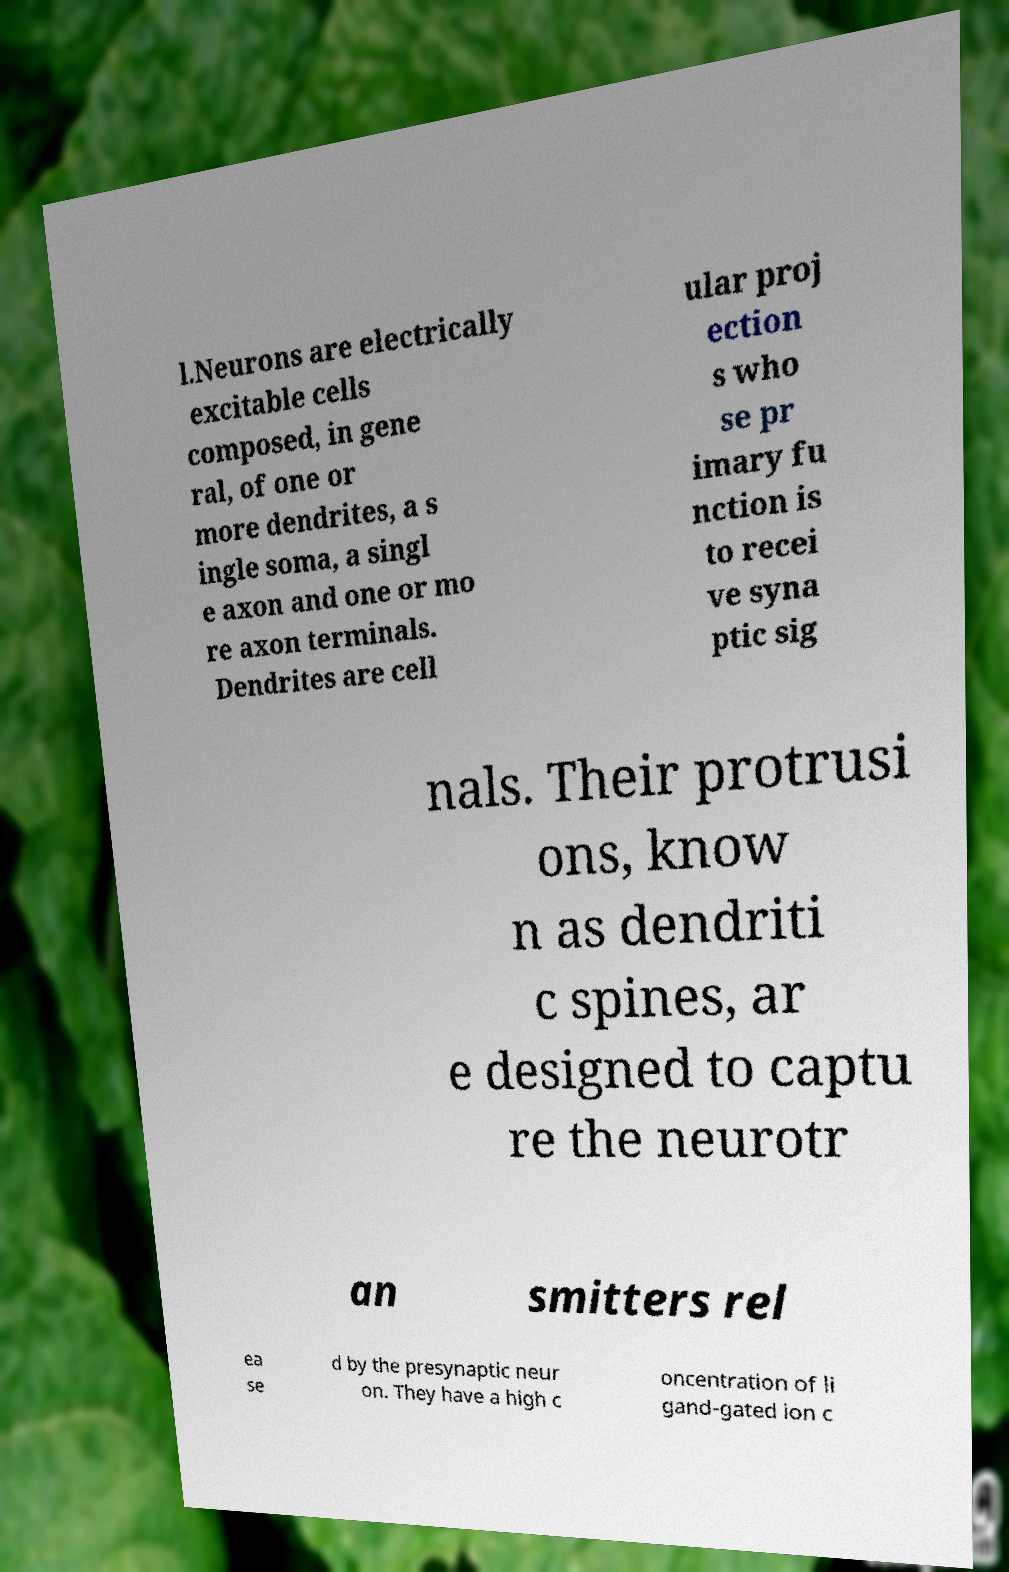Please read and relay the text visible in this image. What does it say? l.Neurons are electrically excitable cells composed, in gene ral, of one or more dendrites, a s ingle soma, a singl e axon and one or mo re axon terminals. Dendrites are cell ular proj ection s who se pr imary fu nction is to recei ve syna ptic sig nals. Their protrusi ons, know n as dendriti c spines, ar e designed to captu re the neurotr an smitters rel ea se d by the presynaptic neur on. They have a high c oncentration of li gand-gated ion c 